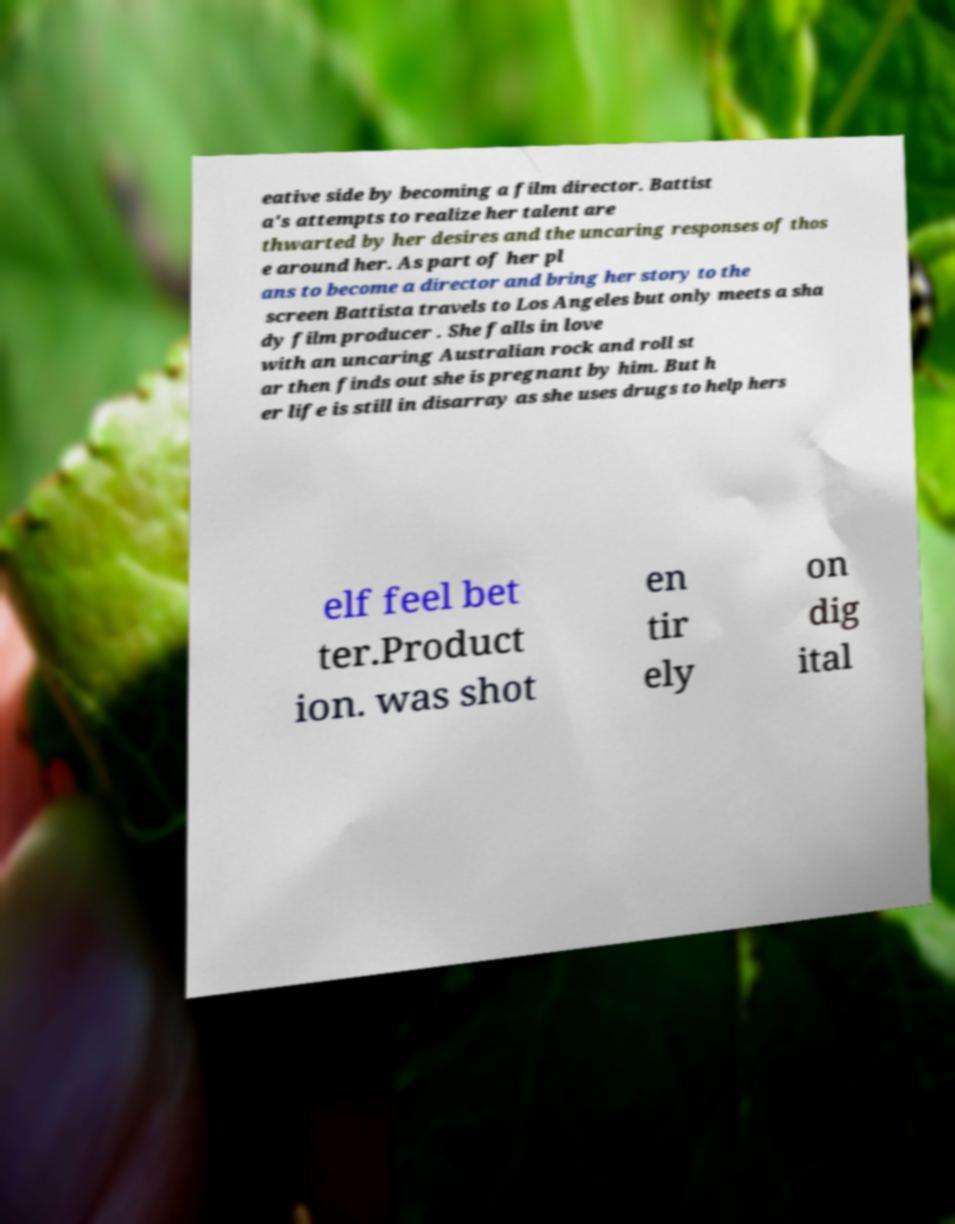Can you read and provide the text displayed in the image?This photo seems to have some interesting text. Can you extract and type it out for me? eative side by becoming a film director. Battist a's attempts to realize her talent are thwarted by her desires and the uncaring responses of thos e around her. As part of her pl ans to become a director and bring her story to the screen Battista travels to Los Angeles but only meets a sha dy film producer . She falls in love with an uncaring Australian rock and roll st ar then finds out she is pregnant by him. But h er life is still in disarray as she uses drugs to help hers elf feel bet ter.Product ion. was shot en tir ely on dig ital 